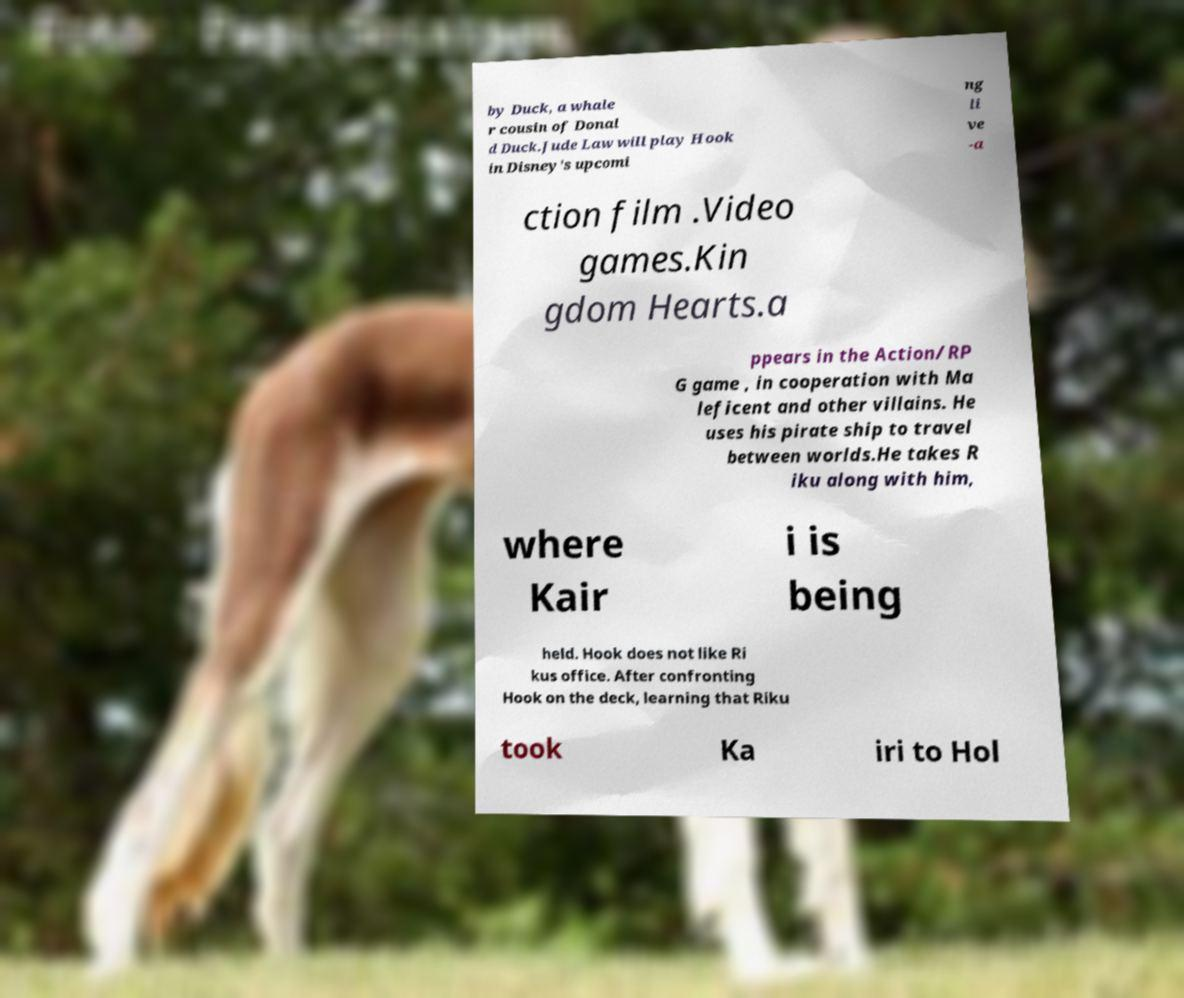There's text embedded in this image that I need extracted. Can you transcribe it verbatim? by Duck, a whale r cousin of Donal d Duck.Jude Law will play Hook in Disney's upcomi ng li ve -a ction film .Video games.Kin gdom Hearts.a ppears in the Action/RP G game , in cooperation with Ma leficent and other villains. He uses his pirate ship to travel between worlds.He takes R iku along with him, where Kair i is being held. Hook does not like Ri kus office. After confronting Hook on the deck, learning that Riku took Ka iri to Hol 